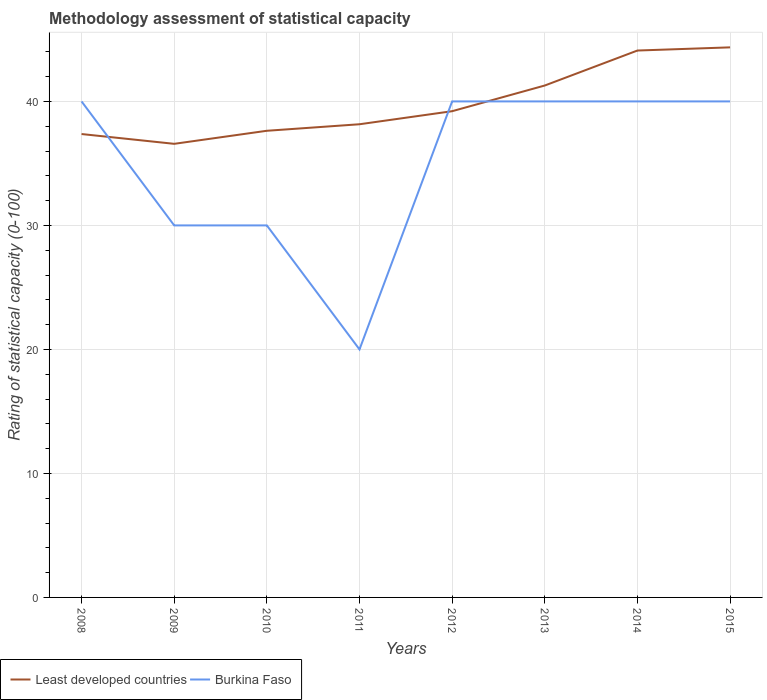Is the number of lines equal to the number of legend labels?
Your answer should be very brief. Yes. Across all years, what is the maximum rating of statistical capacity in Least developed countries?
Give a very brief answer. 36.58. In which year was the rating of statistical capacity in Burkina Faso maximum?
Keep it short and to the point. 2011. What is the difference between the highest and the second highest rating of statistical capacity in Least developed countries?
Ensure brevity in your answer.  7.78. How many lines are there?
Make the answer very short. 2. Are the values on the major ticks of Y-axis written in scientific E-notation?
Make the answer very short. No. What is the title of the graph?
Give a very brief answer. Methodology assessment of statistical capacity. Does "Gambia, The" appear as one of the legend labels in the graph?
Make the answer very short. No. What is the label or title of the X-axis?
Make the answer very short. Years. What is the label or title of the Y-axis?
Ensure brevity in your answer.  Rating of statistical capacity (0-100). What is the Rating of statistical capacity (0-100) of Least developed countries in 2008?
Provide a succinct answer. 37.37. What is the Rating of statistical capacity (0-100) in Burkina Faso in 2008?
Keep it short and to the point. 40. What is the Rating of statistical capacity (0-100) in Least developed countries in 2009?
Your answer should be very brief. 36.58. What is the Rating of statistical capacity (0-100) of Least developed countries in 2010?
Provide a succinct answer. 37.63. What is the Rating of statistical capacity (0-100) in Least developed countries in 2011?
Provide a short and direct response. 38.16. What is the Rating of statistical capacity (0-100) of Least developed countries in 2012?
Offer a very short reply. 39.21. What is the Rating of statistical capacity (0-100) in Least developed countries in 2013?
Ensure brevity in your answer.  41.28. What is the Rating of statistical capacity (0-100) in Least developed countries in 2014?
Provide a succinct answer. 44.1. What is the Rating of statistical capacity (0-100) of Least developed countries in 2015?
Provide a succinct answer. 44.36. Across all years, what is the maximum Rating of statistical capacity (0-100) of Least developed countries?
Ensure brevity in your answer.  44.36. Across all years, what is the minimum Rating of statistical capacity (0-100) of Least developed countries?
Provide a short and direct response. 36.58. What is the total Rating of statistical capacity (0-100) of Least developed countries in the graph?
Provide a short and direct response. 318.69. What is the total Rating of statistical capacity (0-100) in Burkina Faso in the graph?
Offer a very short reply. 280. What is the difference between the Rating of statistical capacity (0-100) in Least developed countries in 2008 and that in 2009?
Offer a very short reply. 0.79. What is the difference between the Rating of statistical capacity (0-100) of Least developed countries in 2008 and that in 2010?
Your answer should be very brief. -0.26. What is the difference between the Rating of statistical capacity (0-100) in Burkina Faso in 2008 and that in 2010?
Your answer should be compact. 10. What is the difference between the Rating of statistical capacity (0-100) in Least developed countries in 2008 and that in 2011?
Your response must be concise. -0.79. What is the difference between the Rating of statistical capacity (0-100) of Least developed countries in 2008 and that in 2012?
Your answer should be very brief. -1.84. What is the difference between the Rating of statistical capacity (0-100) of Burkina Faso in 2008 and that in 2012?
Give a very brief answer. 0. What is the difference between the Rating of statistical capacity (0-100) in Least developed countries in 2008 and that in 2013?
Offer a very short reply. -3.91. What is the difference between the Rating of statistical capacity (0-100) of Burkina Faso in 2008 and that in 2013?
Your response must be concise. 0. What is the difference between the Rating of statistical capacity (0-100) of Least developed countries in 2008 and that in 2014?
Provide a succinct answer. -6.73. What is the difference between the Rating of statistical capacity (0-100) in Burkina Faso in 2008 and that in 2014?
Offer a terse response. 0. What is the difference between the Rating of statistical capacity (0-100) in Least developed countries in 2008 and that in 2015?
Give a very brief answer. -6.99. What is the difference between the Rating of statistical capacity (0-100) of Burkina Faso in 2008 and that in 2015?
Keep it short and to the point. 0. What is the difference between the Rating of statistical capacity (0-100) in Least developed countries in 2009 and that in 2010?
Your answer should be very brief. -1.05. What is the difference between the Rating of statistical capacity (0-100) in Burkina Faso in 2009 and that in 2010?
Your answer should be very brief. 0. What is the difference between the Rating of statistical capacity (0-100) in Least developed countries in 2009 and that in 2011?
Ensure brevity in your answer.  -1.58. What is the difference between the Rating of statistical capacity (0-100) of Least developed countries in 2009 and that in 2012?
Your answer should be compact. -2.63. What is the difference between the Rating of statistical capacity (0-100) of Burkina Faso in 2009 and that in 2012?
Offer a terse response. -10. What is the difference between the Rating of statistical capacity (0-100) in Least developed countries in 2009 and that in 2013?
Provide a short and direct response. -4.7. What is the difference between the Rating of statistical capacity (0-100) in Least developed countries in 2009 and that in 2014?
Ensure brevity in your answer.  -7.52. What is the difference between the Rating of statistical capacity (0-100) in Least developed countries in 2009 and that in 2015?
Keep it short and to the point. -7.78. What is the difference between the Rating of statistical capacity (0-100) of Least developed countries in 2010 and that in 2011?
Ensure brevity in your answer.  -0.53. What is the difference between the Rating of statistical capacity (0-100) in Burkina Faso in 2010 and that in 2011?
Offer a terse response. 10. What is the difference between the Rating of statistical capacity (0-100) in Least developed countries in 2010 and that in 2012?
Give a very brief answer. -1.58. What is the difference between the Rating of statistical capacity (0-100) in Least developed countries in 2010 and that in 2013?
Offer a very short reply. -3.65. What is the difference between the Rating of statistical capacity (0-100) of Least developed countries in 2010 and that in 2014?
Your answer should be very brief. -6.47. What is the difference between the Rating of statistical capacity (0-100) of Least developed countries in 2010 and that in 2015?
Your answer should be compact. -6.73. What is the difference between the Rating of statistical capacity (0-100) in Burkina Faso in 2010 and that in 2015?
Make the answer very short. -10. What is the difference between the Rating of statistical capacity (0-100) in Least developed countries in 2011 and that in 2012?
Provide a short and direct response. -1.05. What is the difference between the Rating of statistical capacity (0-100) in Burkina Faso in 2011 and that in 2012?
Give a very brief answer. -20. What is the difference between the Rating of statistical capacity (0-100) in Least developed countries in 2011 and that in 2013?
Ensure brevity in your answer.  -3.12. What is the difference between the Rating of statistical capacity (0-100) of Burkina Faso in 2011 and that in 2013?
Offer a terse response. -20. What is the difference between the Rating of statistical capacity (0-100) in Least developed countries in 2011 and that in 2014?
Keep it short and to the point. -5.94. What is the difference between the Rating of statistical capacity (0-100) of Burkina Faso in 2011 and that in 2014?
Provide a succinct answer. -20. What is the difference between the Rating of statistical capacity (0-100) of Least developed countries in 2011 and that in 2015?
Offer a very short reply. -6.2. What is the difference between the Rating of statistical capacity (0-100) in Least developed countries in 2012 and that in 2013?
Your response must be concise. -2.07. What is the difference between the Rating of statistical capacity (0-100) of Burkina Faso in 2012 and that in 2013?
Offer a terse response. 0. What is the difference between the Rating of statistical capacity (0-100) in Least developed countries in 2012 and that in 2014?
Offer a terse response. -4.89. What is the difference between the Rating of statistical capacity (0-100) of Burkina Faso in 2012 and that in 2014?
Ensure brevity in your answer.  0. What is the difference between the Rating of statistical capacity (0-100) of Least developed countries in 2012 and that in 2015?
Your answer should be very brief. -5.15. What is the difference between the Rating of statistical capacity (0-100) of Least developed countries in 2013 and that in 2014?
Provide a succinct answer. -2.82. What is the difference between the Rating of statistical capacity (0-100) of Burkina Faso in 2013 and that in 2014?
Give a very brief answer. 0. What is the difference between the Rating of statistical capacity (0-100) of Least developed countries in 2013 and that in 2015?
Offer a very short reply. -3.08. What is the difference between the Rating of statistical capacity (0-100) of Burkina Faso in 2013 and that in 2015?
Provide a succinct answer. 0. What is the difference between the Rating of statistical capacity (0-100) in Least developed countries in 2014 and that in 2015?
Keep it short and to the point. -0.26. What is the difference between the Rating of statistical capacity (0-100) of Burkina Faso in 2014 and that in 2015?
Provide a succinct answer. 0. What is the difference between the Rating of statistical capacity (0-100) in Least developed countries in 2008 and the Rating of statistical capacity (0-100) in Burkina Faso in 2009?
Provide a short and direct response. 7.37. What is the difference between the Rating of statistical capacity (0-100) of Least developed countries in 2008 and the Rating of statistical capacity (0-100) of Burkina Faso in 2010?
Give a very brief answer. 7.37. What is the difference between the Rating of statistical capacity (0-100) in Least developed countries in 2008 and the Rating of statistical capacity (0-100) in Burkina Faso in 2011?
Keep it short and to the point. 17.37. What is the difference between the Rating of statistical capacity (0-100) of Least developed countries in 2008 and the Rating of statistical capacity (0-100) of Burkina Faso in 2012?
Ensure brevity in your answer.  -2.63. What is the difference between the Rating of statistical capacity (0-100) in Least developed countries in 2008 and the Rating of statistical capacity (0-100) in Burkina Faso in 2013?
Offer a terse response. -2.63. What is the difference between the Rating of statistical capacity (0-100) in Least developed countries in 2008 and the Rating of statistical capacity (0-100) in Burkina Faso in 2014?
Offer a terse response. -2.63. What is the difference between the Rating of statistical capacity (0-100) in Least developed countries in 2008 and the Rating of statistical capacity (0-100) in Burkina Faso in 2015?
Give a very brief answer. -2.63. What is the difference between the Rating of statistical capacity (0-100) in Least developed countries in 2009 and the Rating of statistical capacity (0-100) in Burkina Faso in 2010?
Give a very brief answer. 6.58. What is the difference between the Rating of statistical capacity (0-100) in Least developed countries in 2009 and the Rating of statistical capacity (0-100) in Burkina Faso in 2011?
Keep it short and to the point. 16.58. What is the difference between the Rating of statistical capacity (0-100) of Least developed countries in 2009 and the Rating of statistical capacity (0-100) of Burkina Faso in 2012?
Make the answer very short. -3.42. What is the difference between the Rating of statistical capacity (0-100) of Least developed countries in 2009 and the Rating of statistical capacity (0-100) of Burkina Faso in 2013?
Offer a very short reply. -3.42. What is the difference between the Rating of statistical capacity (0-100) of Least developed countries in 2009 and the Rating of statistical capacity (0-100) of Burkina Faso in 2014?
Ensure brevity in your answer.  -3.42. What is the difference between the Rating of statistical capacity (0-100) of Least developed countries in 2009 and the Rating of statistical capacity (0-100) of Burkina Faso in 2015?
Provide a short and direct response. -3.42. What is the difference between the Rating of statistical capacity (0-100) of Least developed countries in 2010 and the Rating of statistical capacity (0-100) of Burkina Faso in 2011?
Offer a very short reply. 17.63. What is the difference between the Rating of statistical capacity (0-100) in Least developed countries in 2010 and the Rating of statistical capacity (0-100) in Burkina Faso in 2012?
Provide a short and direct response. -2.37. What is the difference between the Rating of statistical capacity (0-100) of Least developed countries in 2010 and the Rating of statistical capacity (0-100) of Burkina Faso in 2013?
Ensure brevity in your answer.  -2.37. What is the difference between the Rating of statistical capacity (0-100) in Least developed countries in 2010 and the Rating of statistical capacity (0-100) in Burkina Faso in 2014?
Give a very brief answer. -2.37. What is the difference between the Rating of statistical capacity (0-100) in Least developed countries in 2010 and the Rating of statistical capacity (0-100) in Burkina Faso in 2015?
Offer a terse response. -2.37. What is the difference between the Rating of statistical capacity (0-100) of Least developed countries in 2011 and the Rating of statistical capacity (0-100) of Burkina Faso in 2012?
Keep it short and to the point. -1.84. What is the difference between the Rating of statistical capacity (0-100) in Least developed countries in 2011 and the Rating of statistical capacity (0-100) in Burkina Faso in 2013?
Your answer should be compact. -1.84. What is the difference between the Rating of statistical capacity (0-100) of Least developed countries in 2011 and the Rating of statistical capacity (0-100) of Burkina Faso in 2014?
Your answer should be compact. -1.84. What is the difference between the Rating of statistical capacity (0-100) in Least developed countries in 2011 and the Rating of statistical capacity (0-100) in Burkina Faso in 2015?
Your response must be concise. -1.84. What is the difference between the Rating of statistical capacity (0-100) of Least developed countries in 2012 and the Rating of statistical capacity (0-100) of Burkina Faso in 2013?
Offer a very short reply. -0.79. What is the difference between the Rating of statistical capacity (0-100) of Least developed countries in 2012 and the Rating of statistical capacity (0-100) of Burkina Faso in 2014?
Make the answer very short. -0.79. What is the difference between the Rating of statistical capacity (0-100) of Least developed countries in 2012 and the Rating of statistical capacity (0-100) of Burkina Faso in 2015?
Make the answer very short. -0.79. What is the difference between the Rating of statistical capacity (0-100) of Least developed countries in 2013 and the Rating of statistical capacity (0-100) of Burkina Faso in 2014?
Ensure brevity in your answer.  1.28. What is the difference between the Rating of statistical capacity (0-100) of Least developed countries in 2013 and the Rating of statistical capacity (0-100) of Burkina Faso in 2015?
Offer a very short reply. 1.28. What is the difference between the Rating of statistical capacity (0-100) in Least developed countries in 2014 and the Rating of statistical capacity (0-100) in Burkina Faso in 2015?
Your response must be concise. 4.1. What is the average Rating of statistical capacity (0-100) of Least developed countries per year?
Ensure brevity in your answer.  39.84. What is the average Rating of statistical capacity (0-100) in Burkina Faso per year?
Your answer should be very brief. 35. In the year 2008, what is the difference between the Rating of statistical capacity (0-100) in Least developed countries and Rating of statistical capacity (0-100) in Burkina Faso?
Provide a succinct answer. -2.63. In the year 2009, what is the difference between the Rating of statistical capacity (0-100) of Least developed countries and Rating of statistical capacity (0-100) of Burkina Faso?
Give a very brief answer. 6.58. In the year 2010, what is the difference between the Rating of statistical capacity (0-100) in Least developed countries and Rating of statistical capacity (0-100) in Burkina Faso?
Make the answer very short. 7.63. In the year 2011, what is the difference between the Rating of statistical capacity (0-100) in Least developed countries and Rating of statistical capacity (0-100) in Burkina Faso?
Your answer should be very brief. 18.16. In the year 2012, what is the difference between the Rating of statistical capacity (0-100) in Least developed countries and Rating of statistical capacity (0-100) in Burkina Faso?
Your answer should be very brief. -0.79. In the year 2013, what is the difference between the Rating of statistical capacity (0-100) in Least developed countries and Rating of statistical capacity (0-100) in Burkina Faso?
Keep it short and to the point. 1.28. In the year 2014, what is the difference between the Rating of statistical capacity (0-100) in Least developed countries and Rating of statistical capacity (0-100) in Burkina Faso?
Your answer should be very brief. 4.1. In the year 2015, what is the difference between the Rating of statistical capacity (0-100) of Least developed countries and Rating of statistical capacity (0-100) of Burkina Faso?
Offer a terse response. 4.36. What is the ratio of the Rating of statistical capacity (0-100) of Least developed countries in 2008 to that in 2009?
Provide a short and direct response. 1.02. What is the ratio of the Rating of statistical capacity (0-100) in Burkina Faso in 2008 to that in 2009?
Keep it short and to the point. 1.33. What is the ratio of the Rating of statistical capacity (0-100) of Least developed countries in 2008 to that in 2010?
Give a very brief answer. 0.99. What is the ratio of the Rating of statistical capacity (0-100) of Least developed countries in 2008 to that in 2011?
Your answer should be very brief. 0.98. What is the ratio of the Rating of statistical capacity (0-100) of Burkina Faso in 2008 to that in 2011?
Your response must be concise. 2. What is the ratio of the Rating of statistical capacity (0-100) in Least developed countries in 2008 to that in 2012?
Ensure brevity in your answer.  0.95. What is the ratio of the Rating of statistical capacity (0-100) of Least developed countries in 2008 to that in 2013?
Your response must be concise. 0.91. What is the ratio of the Rating of statistical capacity (0-100) of Burkina Faso in 2008 to that in 2013?
Provide a short and direct response. 1. What is the ratio of the Rating of statistical capacity (0-100) of Least developed countries in 2008 to that in 2014?
Your response must be concise. 0.85. What is the ratio of the Rating of statistical capacity (0-100) in Least developed countries in 2008 to that in 2015?
Your response must be concise. 0.84. What is the ratio of the Rating of statistical capacity (0-100) in Burkina Faso in 2008 to that in 2015?
Keep it short and to the point. 1. What is the ratio of the Rating of statistical capacity (0-100) of Least developed countries in 2009 to that in 2010?
Your answer should be compact. 0.97. What is the ratio of the Rating of statistical capacity (0-100) of Burkina Faso in 2009 to that in 2010?
Your answer should be very brief. 1. What is the ratio of the Rating of statistical capacity (0-100) of Least developed countries in 2009 to that in 2011?
Your answer should be very brief. 0.96. What is the ratio of the Rating of statistical capacity (0-100) in Least developed countries in 2009 to that in 2012?
Provide a succinct answer. 0.93. What is the ratio of the Rating of statistical capacity (0-100) of Least developed countries in 2009 to that in 2013?
Give a very brief answer. 0.89. What is the ratio of the Rating of statistical capacity (0-100) of Burkina Faso in 2009 to that in 2013?
Make the answer very short. 0.75. What is the ratio of the Rating of statistical capacity (0-100) of Least developed countries in 2009 to that in 2014?
Provide a succinct answer. 0.83. What is the ratio of the Rating of statistical capacity (0-100) of Least developed countries in 2009 to that in 2015?
Provide a short and direct response. 0.82. What is the ratio of the Rating of statistical capacity (0-100) in Least developed countries in 2010 to that in 2011?
Offer a terse response. 0.99. What is the ratio of the Rating of statistical capacity (0-100) of Burkina Faso in 2010 to that in 2011?
Provide a short and direct response. 1.5. What is the ratio of the Rating of statistical capacity (0-100) of Least developed countries in 2010 to that in 2012?
Provide a short and direct response. 0.96. What is the ratio of the Rating of statistical capacity (0-100) in Burkina Faso in 2010 to that in 2012?
Offer a terse response. 0.75. What is the ratio of the Rating of statistical capacity (0-100) in Least developed countries in 2010 to that in 2013?
Keep it short and to the point. 0.91. What is the ratio of the Rating of statistical capacity (0-100) of Burkina Faso in 2010 to that in 2013?
Provide a short and direct response. 0.75. What is the ratio of the Rating of statistical capacity (0-100) of Least developed countries in 2010 to that in 2014?
Provide a succinct answer. 0.85. What is the ratio of the Rating of statistical capacity (0-100) of Burkina Faso in 2010 to that in 2014?
Offer a very short reply. 0.75. What is the ratio of the Rating of statistical capacity (0-100) of Least developed countries in 2010 to that in 2015?
Offer a very short reply. 0.85. What is the ratio of the Rating of statistical capacity (0-100) of Burkina Faso in 2010 to that in 2015?
Offer a very short reply. 0.75. What is the ratio of the Rating of statistical capacity (0-100) of Least developed countries in 2011 to that in 2012?
Provide a short and direct response. 0.97. What is the ratio of the Rating of statistical capacity (0-100) in Least developed countries in 2011 to that in 2013?
Your response must be concise. 0.92. What is the ratio of the Rating of statistical capacity (0-100) in Least developed countries in 2011 to that in 2014?
Give a very brief answer. 0.87. What is the ratio of the Rating of statistical capacity (0-100) of Burkina Faso in 2011 to that in 2014?
Your answer should be compact. 0.5. What is the ratio of the Rating of statistical capacity (0-100) of Least developed countries in 2011 to that in 2015?
Make the answer very short. 0.86. What is the ratio of the Rating of statistical capacity (0-100) of Least developed countries in 2012 to that in 2013?
Ensure brevity in your answer.  0.95. What is the ratio of the Rating of statistical capacity (0-100) of Least developed countries in 2012 to that in 2014?
Ensure brevity in your answer.  0.89. What is the ratio of the Rating of statistical capacity (0-100) in Burkina Faso in 2012 to that in 2014?
Make the answer very short. 1. What is the ratio of the Rating of statistical capacity (0-100) in Least developed countries in 2012 to that in 2015?
Keep it short and to the point. 0.88. What is the ratio of the Rating of statistical capacity (0-100) in Least developed countries in 2013 to that in 2014?
Keep it short and to the point. 0.94. What is the ratio of the Rating of statistical capacity (0-100) of Least developed countries in 2013 to that in 2015?
Keep it short and to the point. 0.93. What is the ratio of the Rating of statistical capacity (0-100) of Least developed countries in 2014 to that in 2015?
Offer a terse response. 0.99. What is the difference between the highest and the second highest Rating of statistical capacity (0-100) in Least developed countries?
Provide a short and direct response. 0.26. What is the difference between the highest and the second highest Rating of statistical capacity (0-100) in Burkina Faso?
Provide a succinct answer. 0. What is the difference between the highest and the lowest Rating of statistical capacity (0-100) in Least developed countries?
Ensure brevity in your answer.  7.78. 